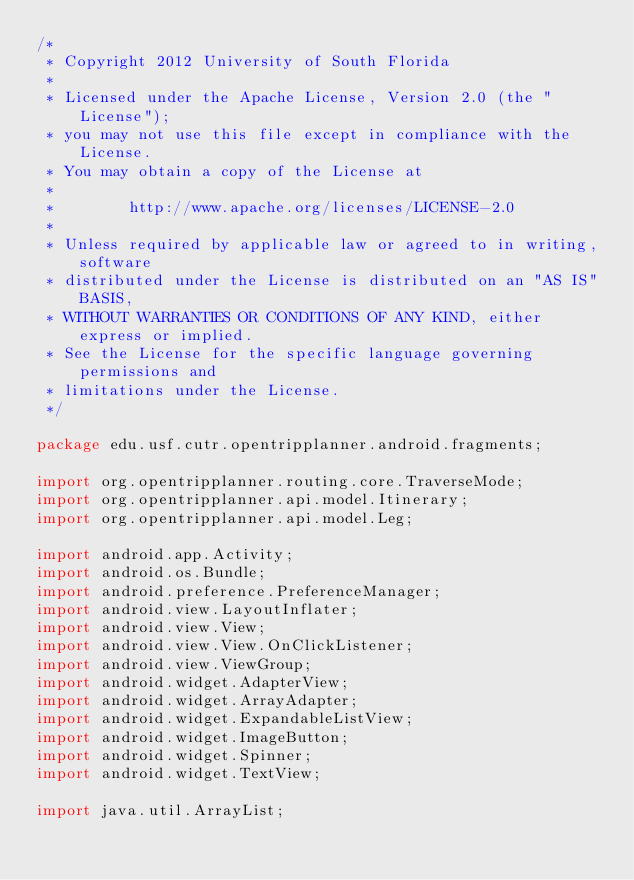Convert code to text. <code><loc_0><loc_0><loc_500><loc_500><_Java_>/*
 * Copyright 2012 University of South Florida
 * 
 * Licensed under the Apache License, Version 2.0 (the "License");
 * you may not use this file except in compliance with the License.
 * You may obtain a copy of the License at
 * 
 *        http://www.apache.org/licenses/LICENSE-2.0
 * 
 * Unless required by applicable law or agreed to in writing, software
 * distributed under the License is distributed on an "AS IS" BASIS,
 * WITHOUT WARRANTIES OR CONDITIONS OF ANY KIND, either express or implied.
 * See the License for the specific language governing permissions and 
 * limitations under the License.
 */

package edu.usf.cutr.opentripplanner.android.fragments;

import org.opentripplanner.routing.core.TraverseMode;
import org.opentripplanner.api.model.Itinerary;
import org.opentripplanner.api.model.Leg;

import android.app.Activity;
import android.os.Bundle;
import android.preference.PreferenceManager;
import android.view.LayoutInflater;
import android.view.View;
import android.view.View.OnClickListener;
import android.view.ViewGroup;
import android.widget.AdapterView;
import android.widget.ArrayAdapter;
import android.widget.ExpandableListView;
import android.widget.ImageButton;
import android.widget.Spinner;
import android.widget.TextView;

import java.util.ArrayList;</code> 